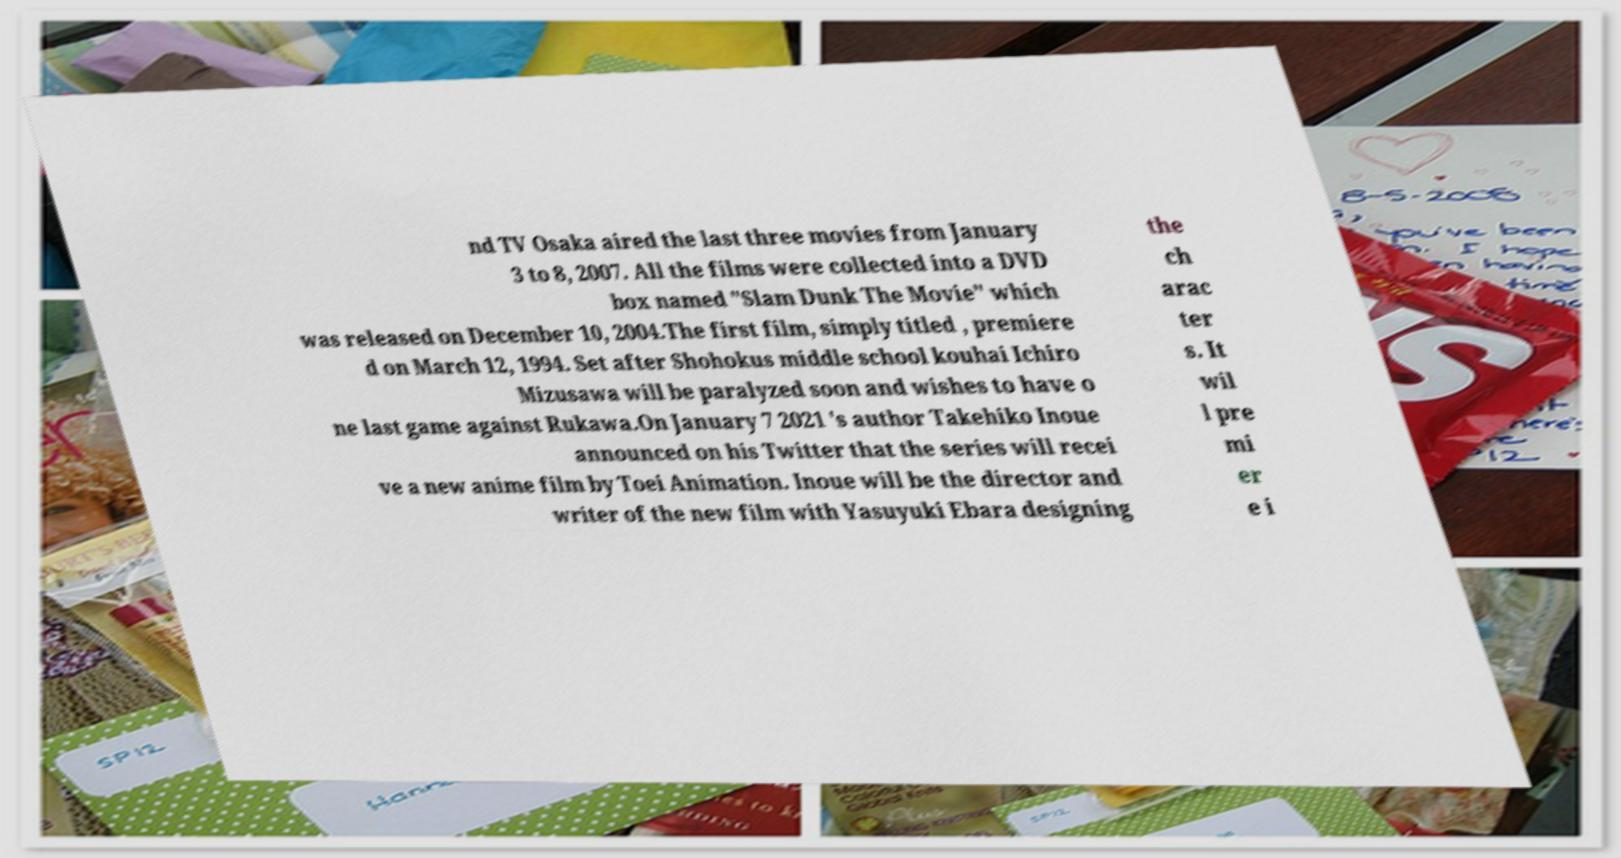I need the written content from this picture converted into text. Can you do that? nd TV Osaka aired the last three movies from January 3 to 8, 2007. All the films were collected into a DVD box named "Slam Dunk The Movie" which was released on December 10, 2004.The first film, simply titled , premiere d on March 12, 1994. Set after Shohokus middle school kouhai Ichiro Mizusawa will be paralyzed soon and wishes to have o ne last game against Rukawa.On January 7 2021 's author Takehiko Inoue announced on his Twitter that the series will recei ve a new anime film by Toei Animation. Inoue will be the director and writer of the new film with Yasuyuki Ebara designing the ch arac ter s. It wil l pre mi er e i 